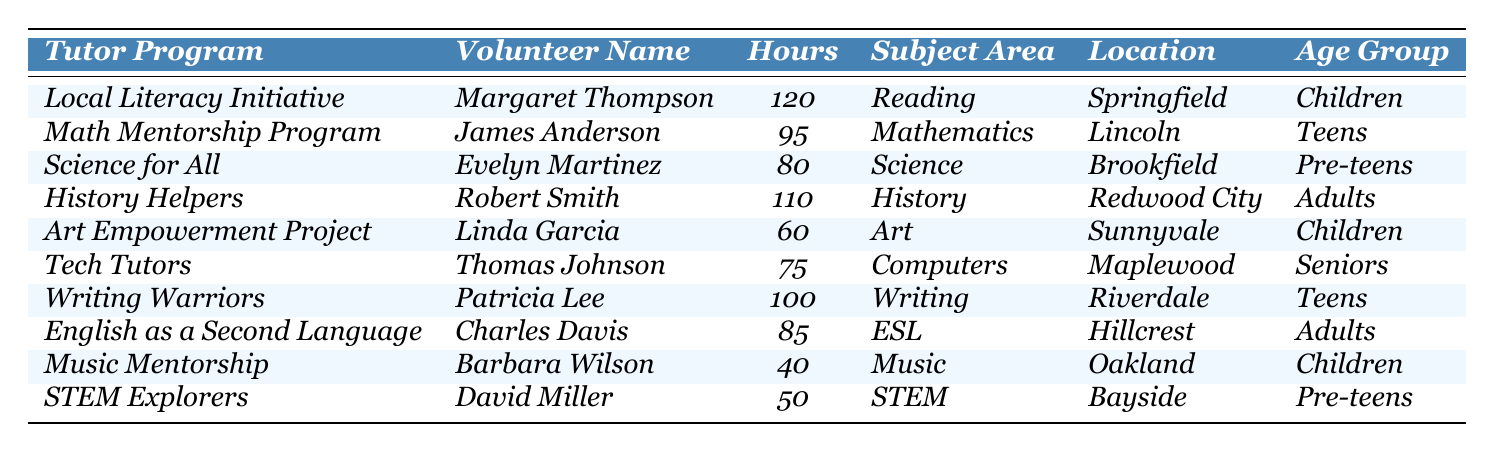What is the total number of volunteer hours contributed by retired educators in the table? To find the total hours, we add up all the hours: 120 + 95 + 80 + 110 + 60 + 75 + 100 + 85 + 40 + 50 = 915.
Answer: 915 Who contributed the most hours, and how many hours did they contribute? By reviewing the hours, Margaret Thompson's 120 hours is the highest.
Answer: Margaret Thompson, 120 hours How many participants volunteered for programs related to children? The programs associated with children are 'Local Literacy Initiative', 'Art Empowerment Project', and 'Music Mentorship', which count as 3 participants.
Answer: 3 Is there any tutor who contributed fewer than 50 hours? No, the least contribution is 40 hours by Barbara Wilson. Since it's not fewer than 50, the answer is no.
Answer: No What is the average number of hours contributed by retired educators in the math-related programs? The math-related programs are 'Math Mentorship Program' and 'Writing Warriors'. Their hours are 95 and 100, summing to 195; with 2 participants, the average is 195/2 = 97.5.
Answer: 97.5 Which subject area had the least volunteer hours contributed and how many hours were recorded? The subject area with the least hours is 'Music' by Barbara Wilson with 40 hours.
Answer: Music, 40 hours How many volunteers contributed to the ESL program, and what was the total contribution? Only Charles Davis contributes to the ESL program with an hour contribution of 85. Therefore, 1 volunteer contributed 85 hours.
Answer: 1, 85 hours If we combine 'Teens' and 'Pre-teens', what is the total number of hours contributed to those age groups? The hours for 'Teens' are 95 + 100 = 195, and for 'Pre-teens', the hours are 80 + 50 = 130. Thus, the total is 195 + 130 = 325.
Answer: 325 Is there any volunteer who contributed to two or more tutoring programs? Based on the table, there is no mention of any volunteer contributing to more than one program, so the answer is no.
Answer: No What age group had the highest total volunteer hours? 'Adults' contributed 110 + 85 = 195 hours. This is observed against others, confirming it's the highest grouping total.
Answer: Adults, 195 hours 